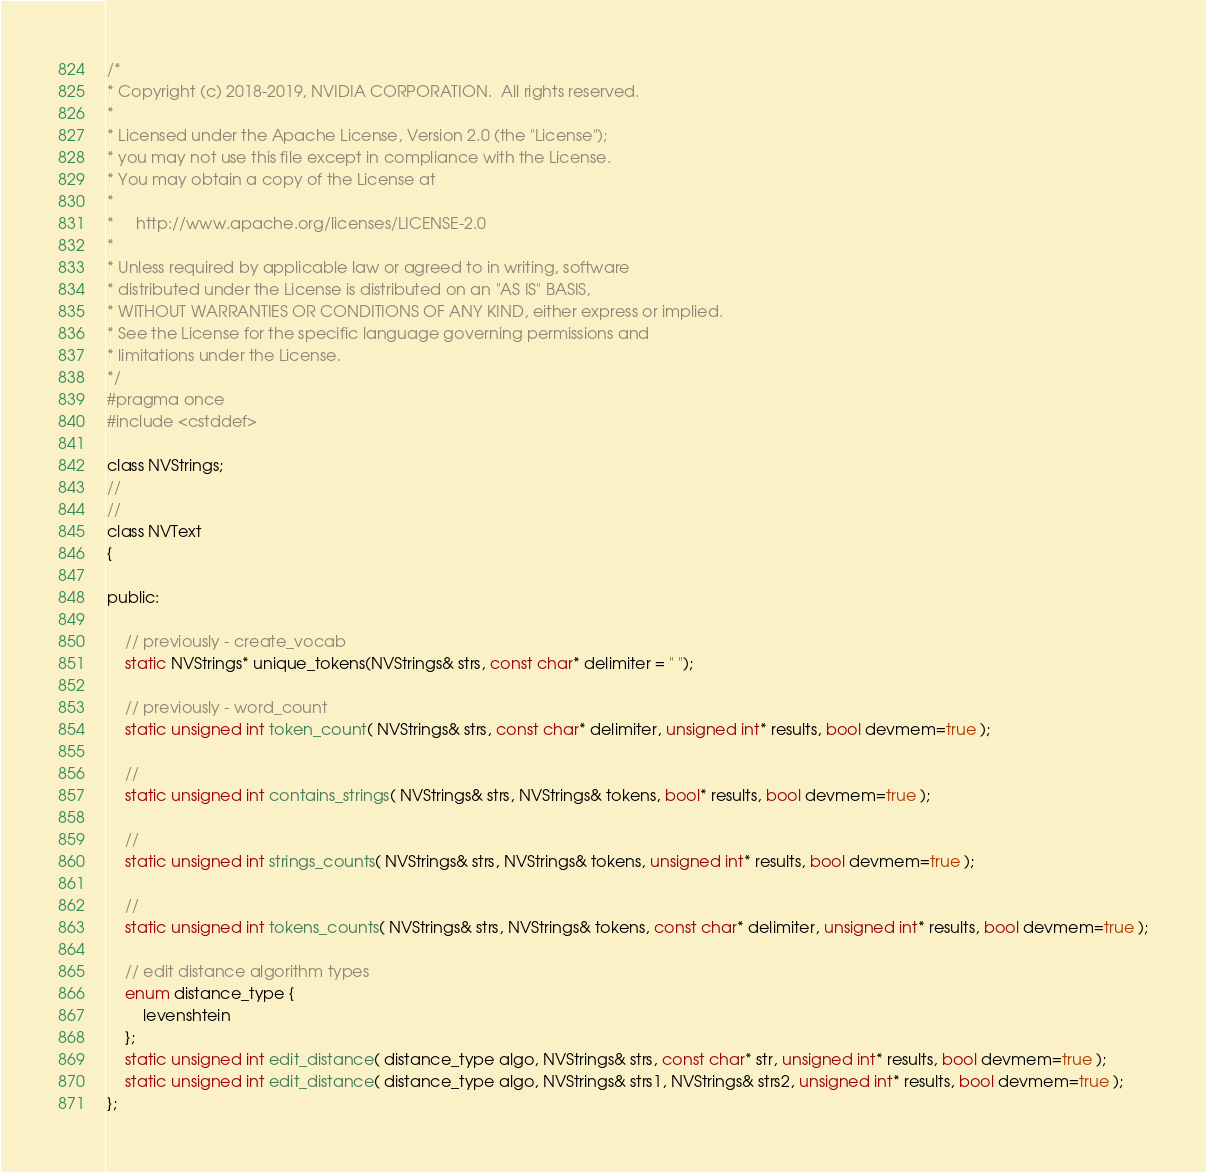Convert code to text. <code><loc_0><loc_0><loc_500><loc_500><_C_>/*
* Copyright (c) 2018-2019, NVIDIA CORPORATION.  All rights reserved.
*
* Licensed under the Apache License, Version 2.0 (the "License");
* you may not use this file except in compliance with the License.
* You may obtain a copy of the License at
*
*     http://www.apache.org/licenses/LICENSE-2.0
*
* Unless required by applicable law or agreed to in writing, software
* distributed under the License is distributed on an "AS IS" BASIS,
* WITHOUT WARRANTIES OR CONDITIONS OF ANY KIND, either express or implied.
* See the License for the specific language governing permissions and
* limitations under the License.
*/
#pragma once
#include <cstddef>

class NVStrings;
//
//
class NVText
{

public:

    // previously - create_vocab
    static NVStrings* unique_tokens(NVStrings& strs, const char* delimiter = " ");

    // previously - word_count
    static unsigned int token_count( NVStrings& strs, const char* delimiter, unsigned int* results, bool devmem=true );

    //
    static unsigned int contains_strings( NVStrings& strs, NVStrings& tokens, bool* results, bool devmem=true );

    //
    static unsigned int strings_counts( NVStrings& strs, NVStrings& tokens, unsigned int* results, bool devmem=true );

    //
    static unsigned int tokens_counts( NVStrings& strs, NVStrings& tokens, const char* delimiter, unsigned int* results, bool devmem=true );

    // edit distance algorithm types
    enum distance_type {
        levenshtein
    };
    static unsigned int edit_distance( distance_type algo, NVStrings& strs, const char* str, unsigned int* results, bool devmem=true );
    static unsigned int edit_distance( distance_type algo, NVStrings& strs1, NVStrings& strs2, unsigned int* results, bool devmem=true );
};
</code> 